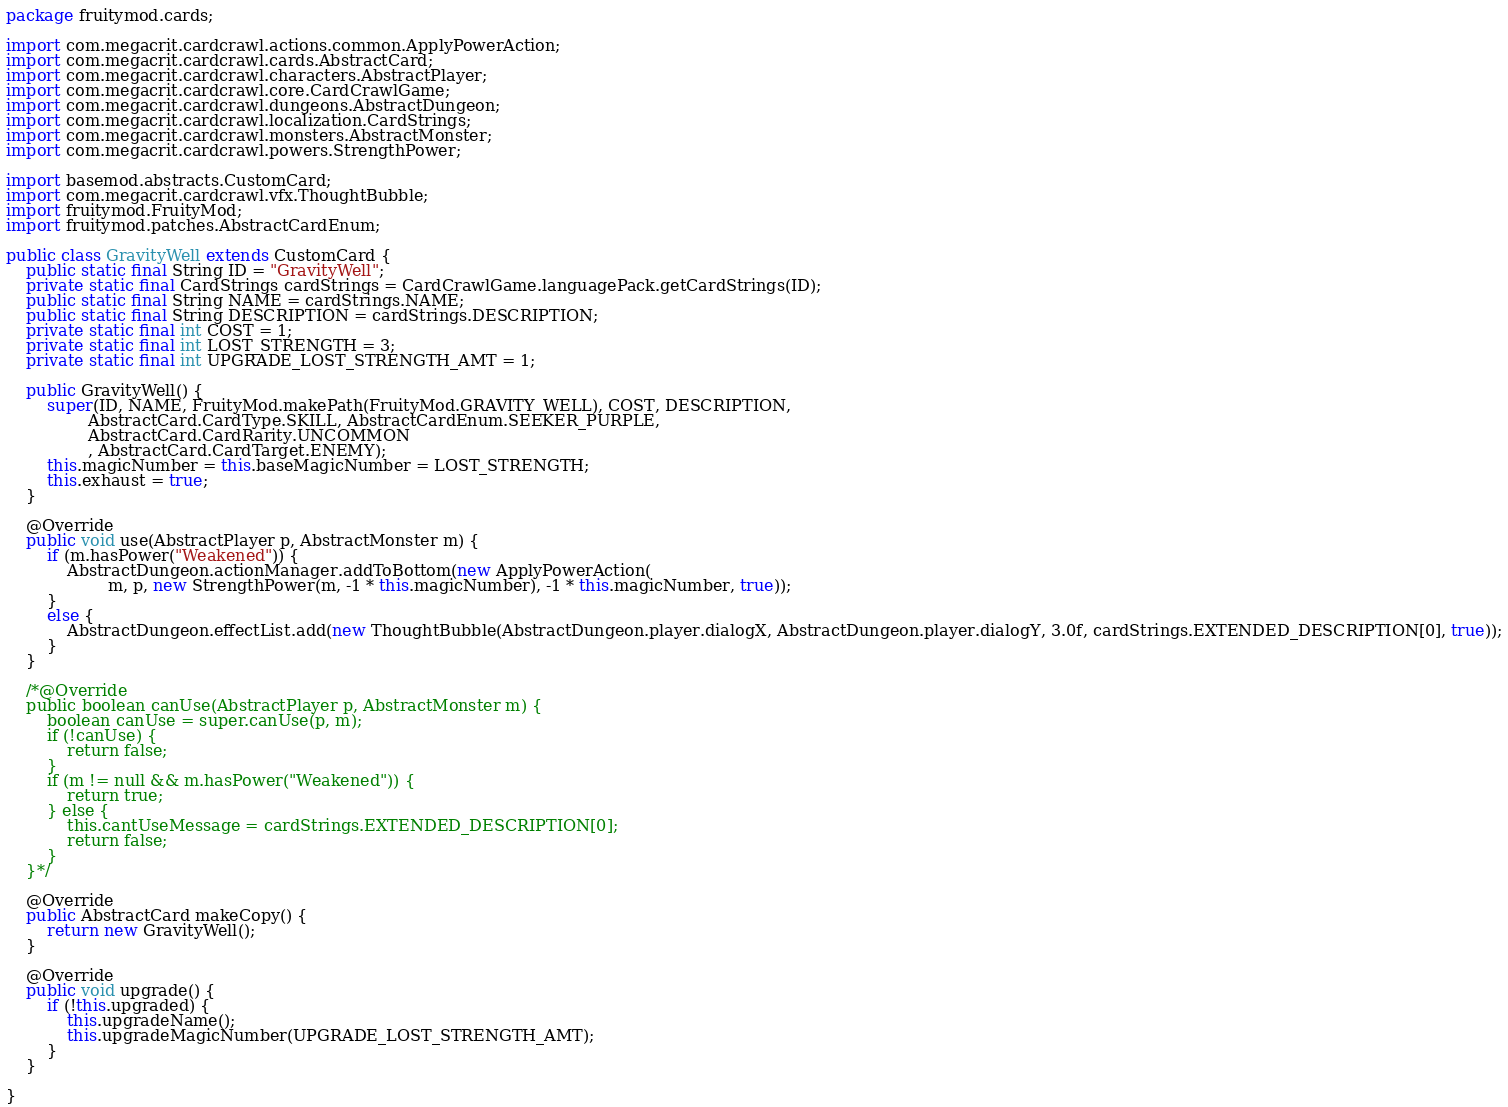<code> <loc_0><loc_0><loc_500><loc_500><_Java_>package fruitymod.cards;

import com.megacrit.cardcrawl.actions.common.ApplyPowerAction;
import com.megacrit.cardcrawl.cards.AbstractCard;
import com.megacrit.cardcrawl.characters.AbstractPlayer;
import com.megacrit.cardcrawl.core.CardCrawlGame;
import com.megacrit.cardcrawl.dungeons.AbstractDungeon;
import com.megacrit.cardcrawl.localization.CardStrings;
import com.megacrit.cardcrawl.monsters.AbstractMonster;
import com.megacrit.cardcrawl.powers.StrengthPower;

import basemod.abstracts.CustomCard;
import com.megacrit.cardcrawl.vfx.ThoughtBubble;
import fruitymod.FruityMod;
import fruitymod.patches.AbstractCardEnum;

public class GravityWell extends CustomCard {
	public static final String ID = "GravityWell";
	private static final CardStrings cardStrings = CardCrawlGame.languagePack.getCardStrings(ID);
	public static final String NAME = cardStrings.NAME;
	public static final String DESCRIPTION = cardStrings.DESCRIPTION;
	private static final int COST = 1;
	private static final int LOST_STRENGTH = 3;
	private static final int UPGRADE_LOST_STRENGTH_AMT = 1;
	
	public GravityWell() {
		super(ID, NAME, FruityMod.makePath(FruityMod.GRAVITY_WELL), COST, DESCRIPTION,
				AbstractCard.CardType.SKILL, AbstractCardEnum.SEEKER_PURPLE,
				AbstractCard.CardRarity.UNCOMMON
				, AbstractCard.CardTarget.ENEMY);
		this.magicNumber = this.baseMagicNumber = LOST_STRENGTH;
		this.exhaust = true;
	}
	
	@Override
	public void use(AbstractPlayer p, AbstractMonster m) {
		if (m.hasPower("Weakened")) {
			AbstractDungeon.actionManager.addToBottom(new ApplyPowerAction(
					m, p, new StrengthPower(m, -1 * this.magicNumber), -1 * this.magicNumber, true));
		}
		else {
			AbstractDungeon.effectList.add(new ThoughtBubble(AbstractDungeon.player.dialogX, AbstractDungeon.player.dialogY, 3.0f, cardStrings.EXTENDED_DESCRIPTION[0], true));
		}
	}
	
	/*@Override
	public boolean canUse(AbstractPlayer p, AbstractMonster m) {
		boolean canUse = super.canUse(p, m);
		if (!canUse) {
			return false;
		}
		if (m != null && m.hasPower("Weakened")) {
			return true;
		} else {
			this.cantUseMessage = cardStrings.EXTENDED_DESCRIPTION[0];
			return false;
		}
	}*/
	
	@Override
	public AbstractCard makeCopy() {
		return new GravityWell();
	}
	
	@Override
	public void upgrade() {
		if (!this.upgraded) {
			this.upgradeName();
			this.upgradeMagicNumber(UPGRADE_LOST_STRENGTH_AMT);
		}
	}
	
}
</code> 